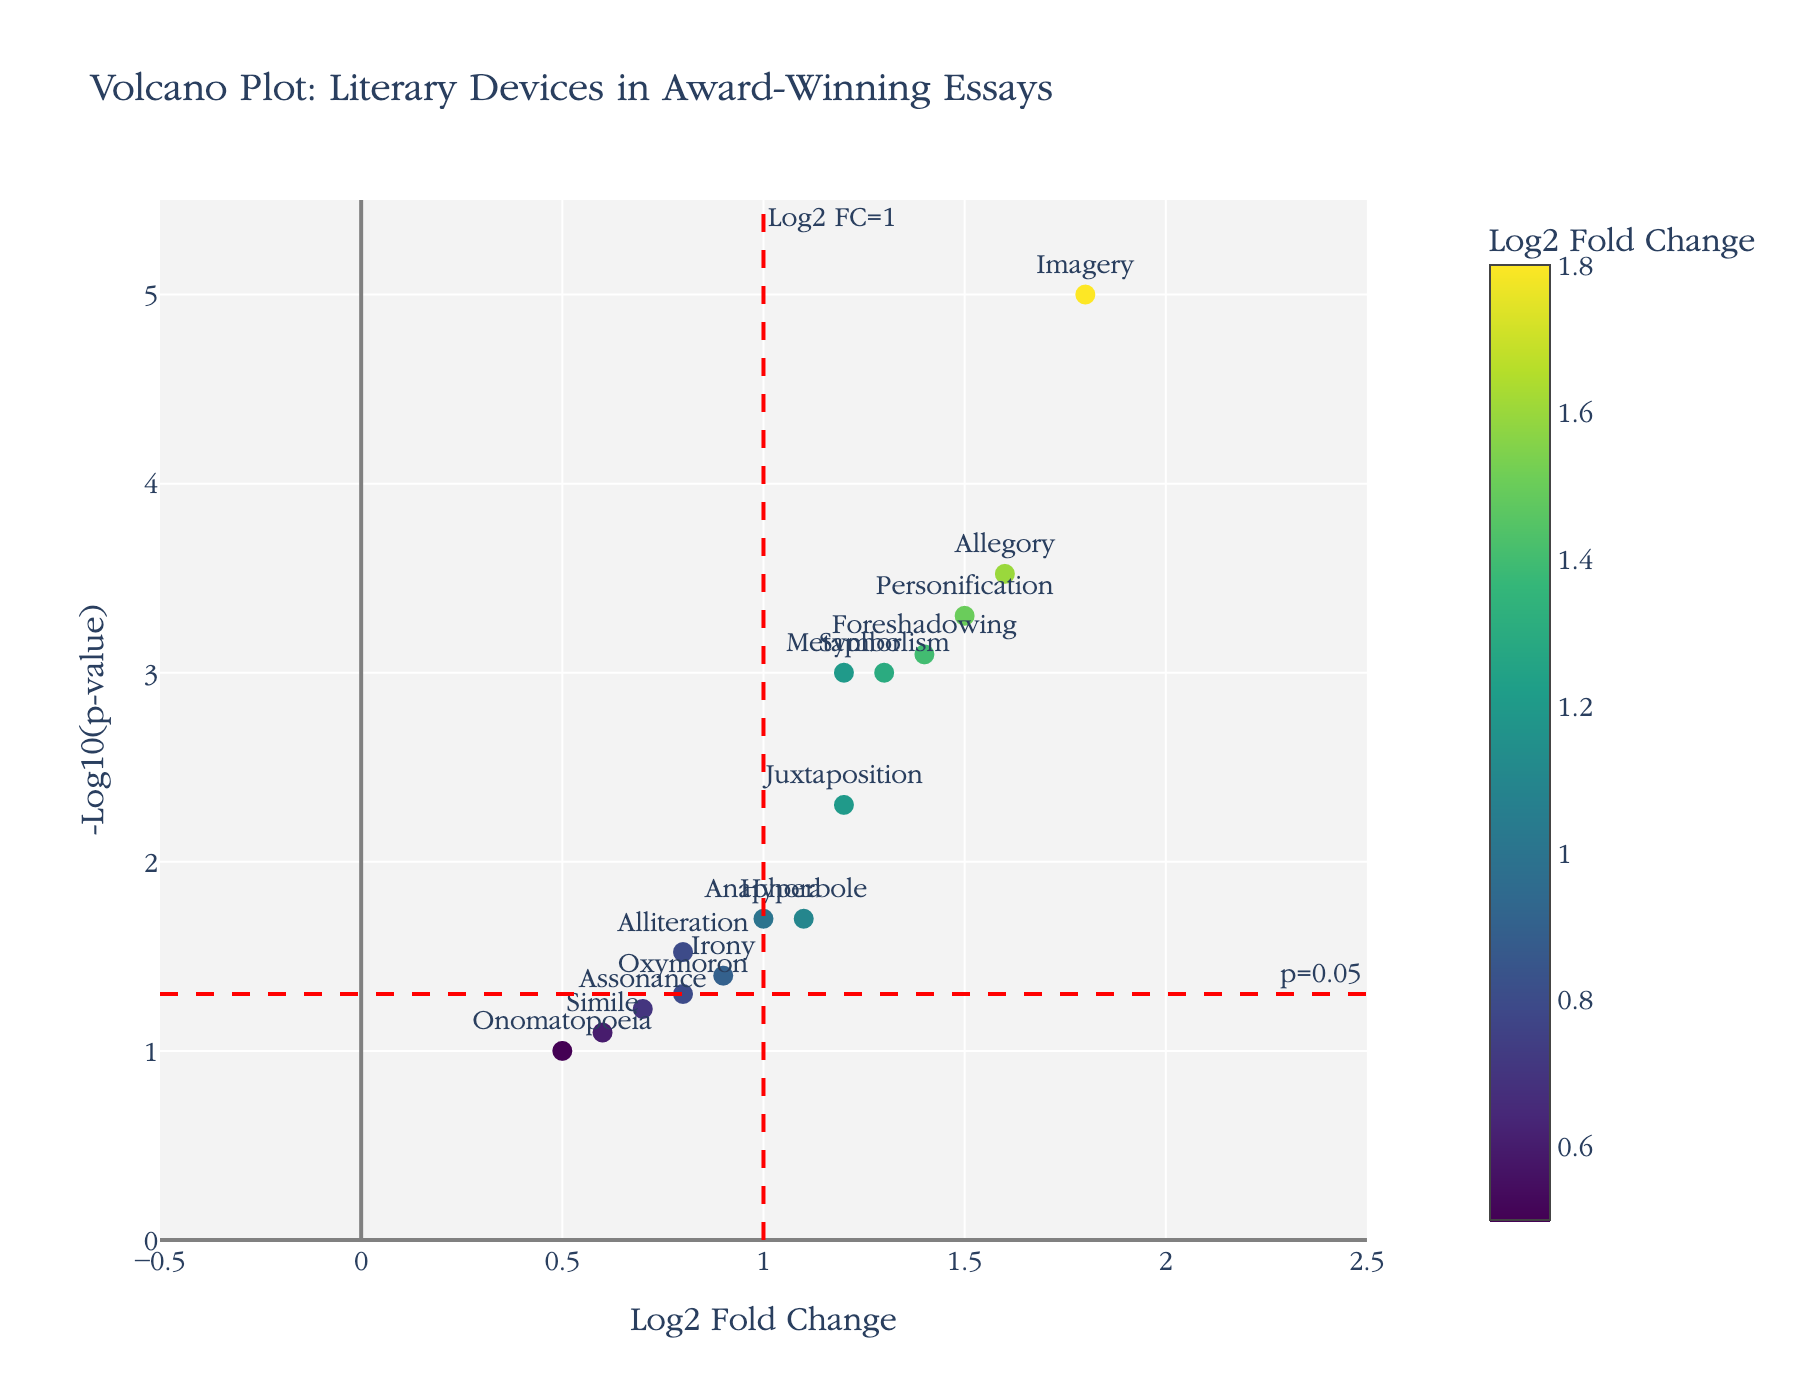What is the title of the figure? The title is usually found at the top of the figure, providing a summary of its contents. In this case, it states: "Volcano Plot: Literary Devices in Award-Winning Essays".
Answer: Volcano Plot: Literary Devices in Award-Winning Essays Which literary device has the highest statistical significance? Statistical significance is usually indicated by the highest -log10(p-value). The highest point on the y-axis corresponds to Imagery.
Answer: Imagery What do the red dashed lines indicate on the plot? The red dashed lines are commonly used to indicate thresholds. In this plot, the horizontal line marks p=0.05 and the vertical line marks Log2 FC=1.
Answer: Significance thresholds for p-value and Log2 FC How many literary devices have a -log10(p-value) greater than 3? Look for data points above 3 on the y-axis. There are Imagery, Personification, Foreshadowing, and Allegory, which makes 4.
Answer: 4 Is the use of Metaphor significantly different in award-winning essays compared to non-winning submissions? To determine significance, check if Metaphor is above the horizontal red line (p=0.05). Metaphor is above this line, indicating it is significant.
Answer: Yes Which literary devices have a Log2 Fold Change greater than 1 and are statistically significant? Look for points to the right of the vertical line (Log2 FC = 1) and above the horizontal line (p=0.05). The devices are Metaphor, Personification, Symbolism, Foreshadowing, and Allegory.
Answer: Metaphor, Personification, Symbolism, Foreshadowing, Allegory How does the use of Hyperbole compare to Irony in terms of p-value? Compare the y-axis positions (-log10(p-value)) of Hyperbole and Irony. Hyperbole is higher up on the y-axis than Irony, indicating a smaller p-value.
Answer: Hyperbole has a smaller p-value than Irony What is the Log2 Fold Change for Anaphora, and is it above the significance threshold? Find Anaphora's position on the x-axis. It is at Log2 FC = 1.0, which is right at the vertical threshold (but not greater).
Answer: 1.0, not above Are any literary devices both non-significant and have a Log2 Fold Change less than 1? Look below the horizontal line (p=0.05) and to the left of the vertical line (Log2 FC = 1). Simile, Onomatopoeia, and Assonance fit this criterion.
Answer: Simile, Onomatopoeia, Assonance 